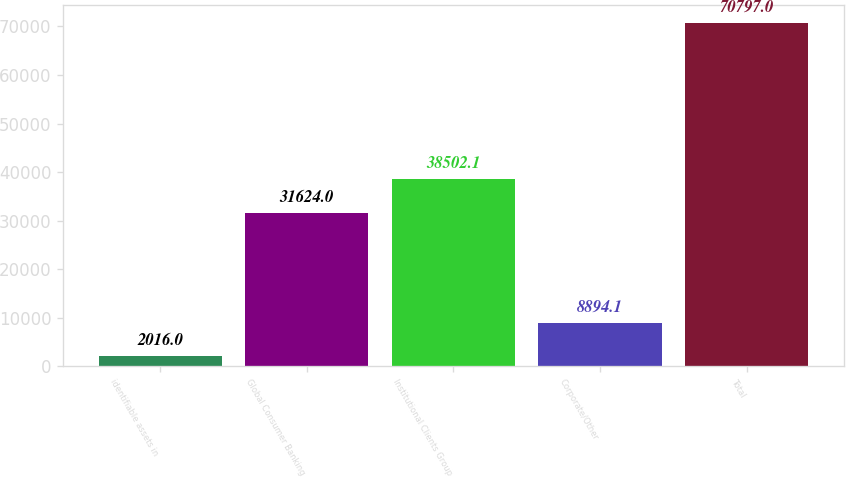Convert chart to OTSL. <chart><loc_0><loc_0><loc_500><loc_500><bar_chart><fcel>identifiable assets in<fcel>Global Consumer Banking<fcel>Institutional Clients Group<fcel>Corporate/Other<fcel>Total<nl><fcel>2016<fcel>31624<fcel>38502.1<fcel>8894.1<fcel>70797<nl></chart> 